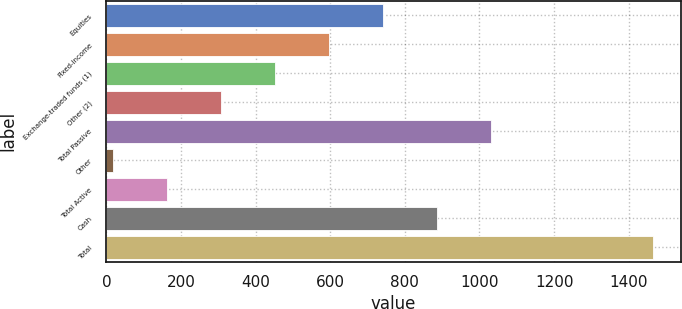<chart> <loc_0><loc_0><loc_500><loc_500><bar_chart><fcel>Equities<fcel>Fixed-income<fcel>Exchange-traded funds (1)<fcel>Other (2)<fcel>Total Passive<fcel>Other<fcel>Total Active<fcel>Cash<fcel>Total<nl><fcel>741.5<fcel>596.6<fcel>451.7<fcel>306.8<fcel>1031.3<fcel>17<fcel>161.9<fcel>886.4<fcel>1466<nl></chart> 